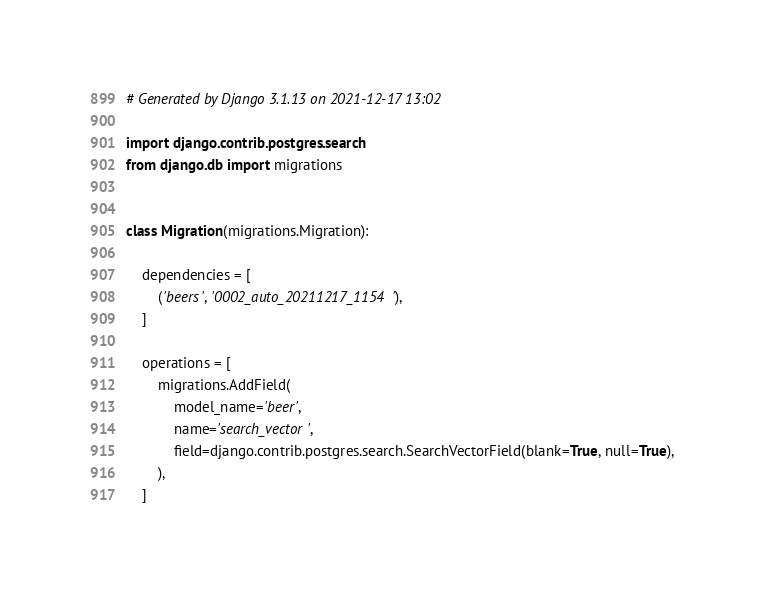Convert code to text. <code><loc_0><loc_0><loc_500><loc_500><_Python_># Generated by Django 3.1.13 on 2021-12-17 13:02

import django.contrib.postgres.search
from django.db import migrations


class Migration(migrations.Migration):

    dependencies = [
        ('beers', '0002_auto_20211217_1154'),
    ]

    operations = [
        migrations.AddField(
            model_name='beer',
            name='search_vector',
            field=django.contrib.postgres.search.SearchVectorField(blank=True, null=True),
        ),
    ]
</code> 